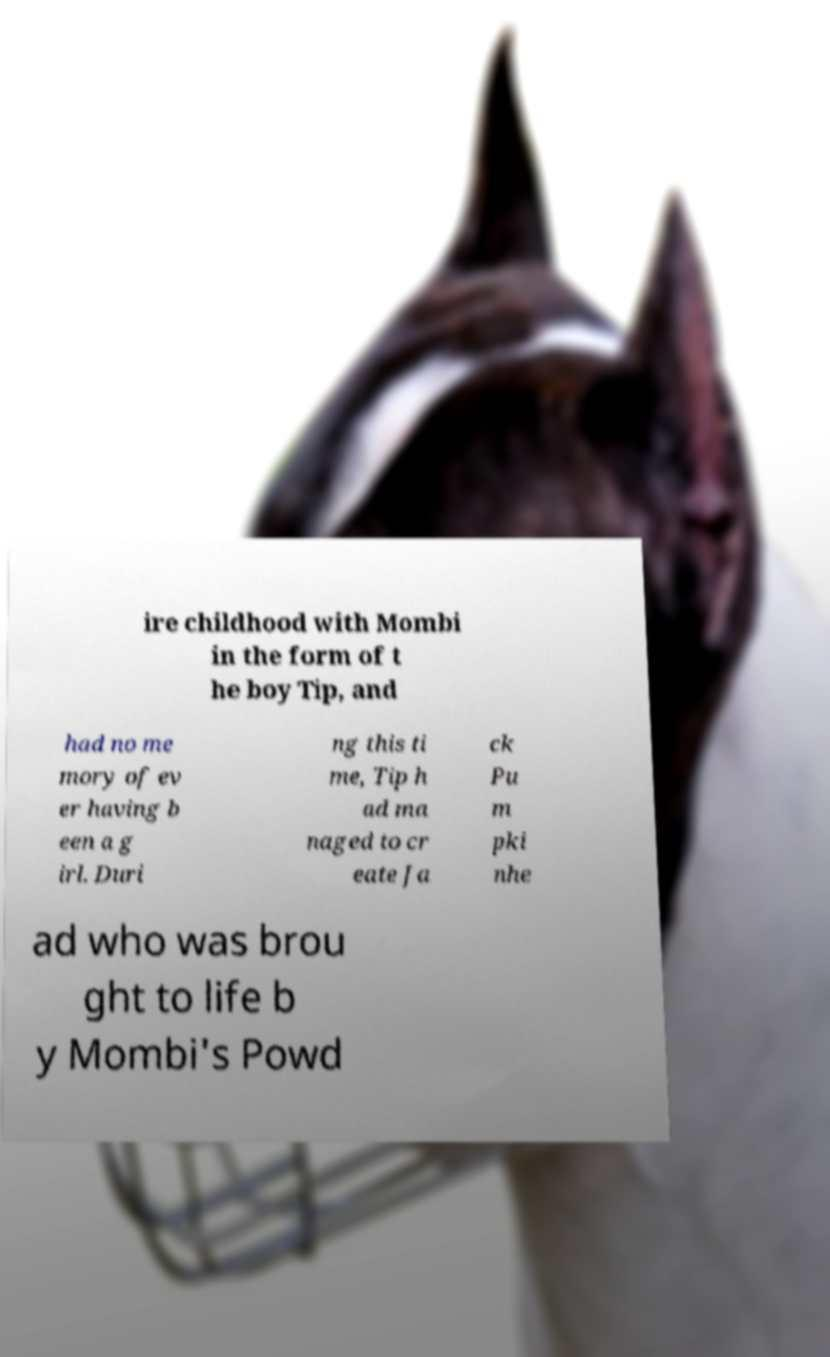Can you read and provide the text displayed in the image?This photo seems to have some interesting text. Can you extract and type it out for me? ire childhood with Mombi in the form of t he boy Tip, and had no me mory of ev er having b een a g irl. Duri ng this ti me, Tip h ad ma naged to cr eate Ja ck Pu m pki nhe ad who was brou ght to life b y Mombi's Powd 